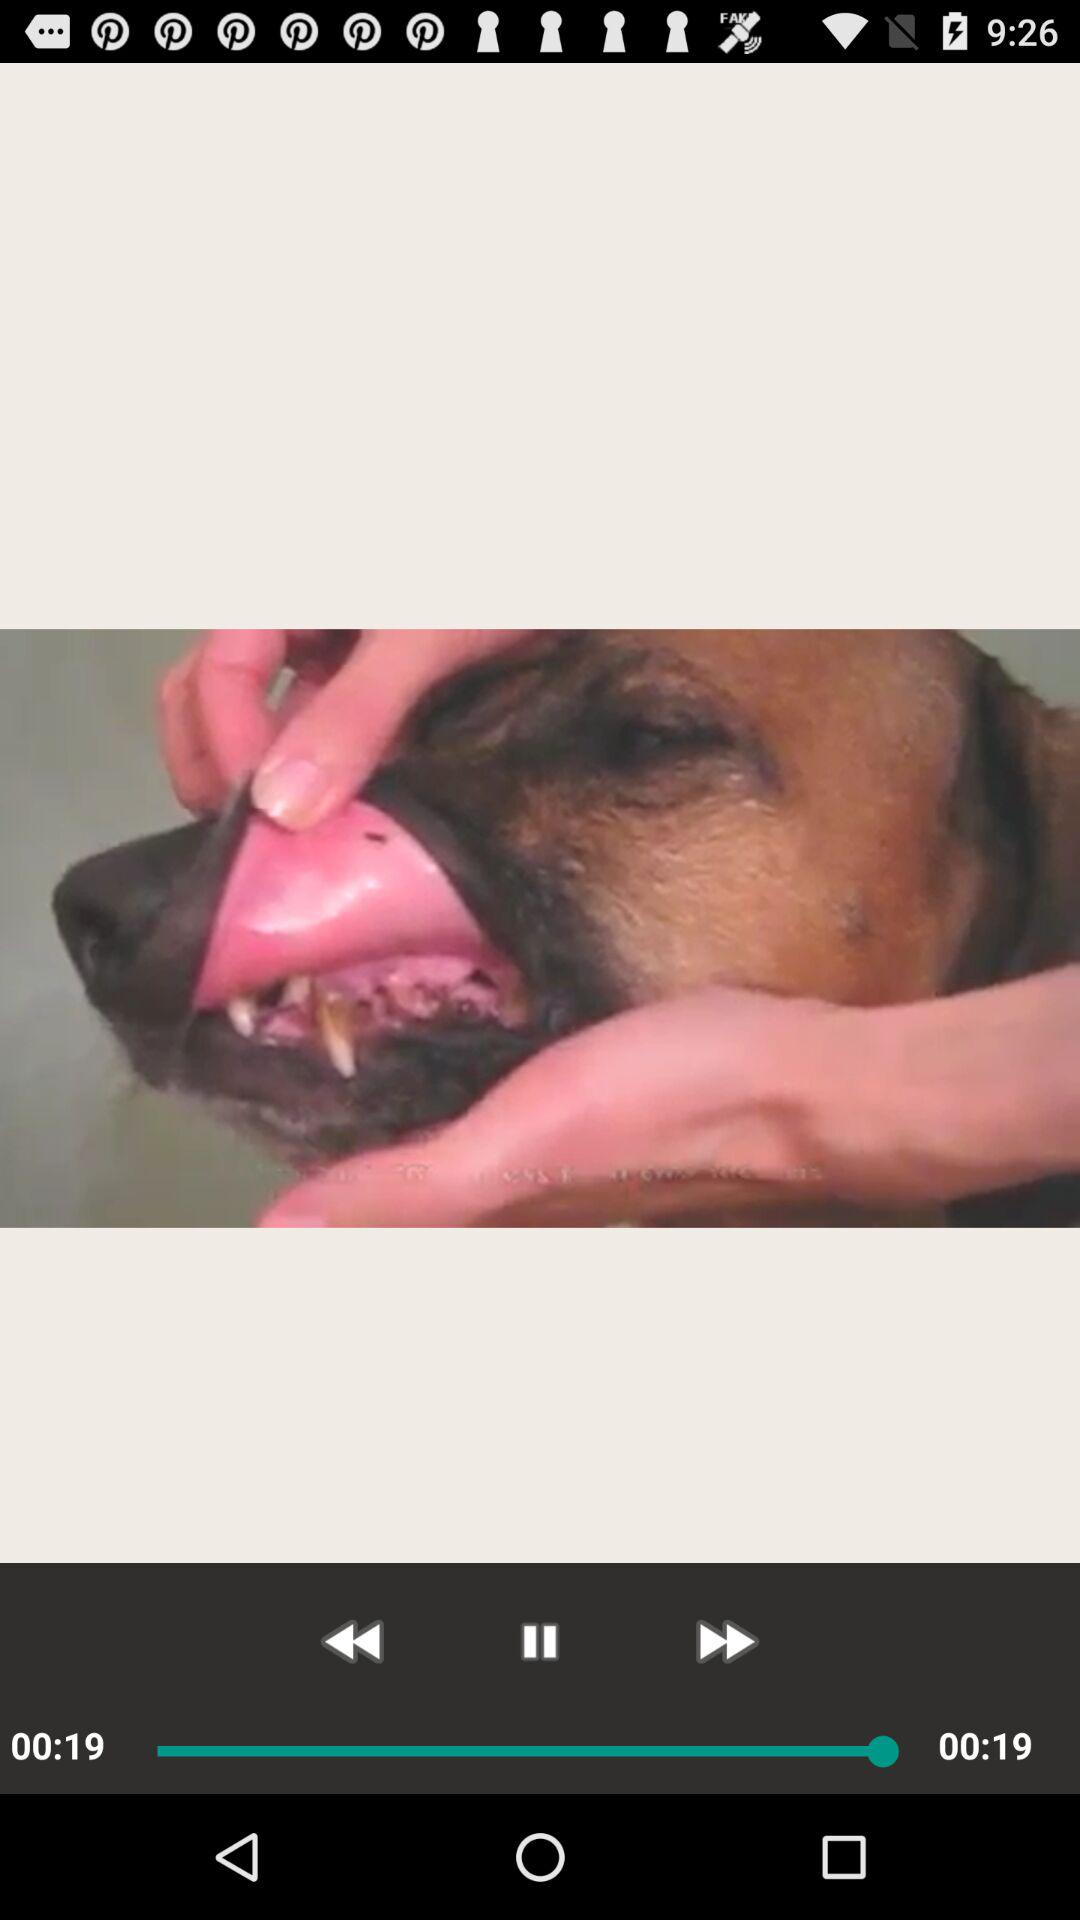What is the duration of the video? The duration of the video is 19 seconds. 